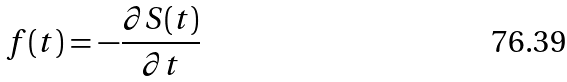<formula> <loc_0><loc_0><loc_500><loc_500>f ( t ) = - \frac { \partial S ( t ) } { \partial t }</formula> 